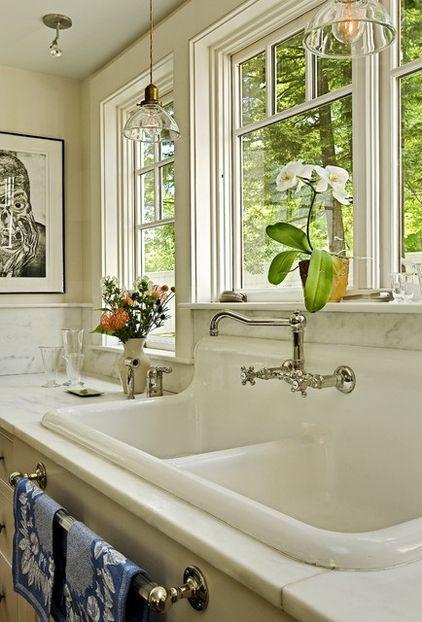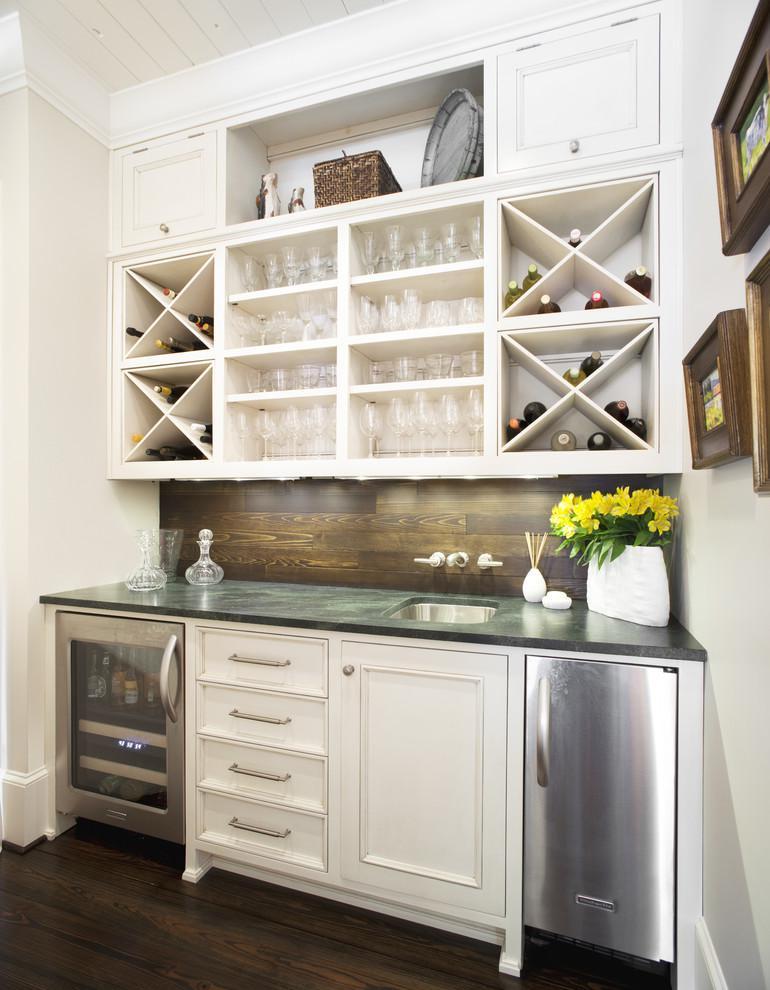The first image is the image on the left, the second image is the image on the right. Considering the images on both sides, is "There is a stainless steel refrigerator  next to an entryway." valid? Answer yes or no. No. The first image is the image on the left, the second image is the image on the right. Considering the images on both sides, is "An image shows a kitchen with white cabinets and a stainless steel refrigerator with """"french doors""""." valid? Answer yes or no. No. 